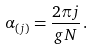<formula> <loc_0><loc_0><loc_500><loc_500>\alpha _ { ( j ) } = \frac { 2 \pi j } { g N } \, .</formula> 